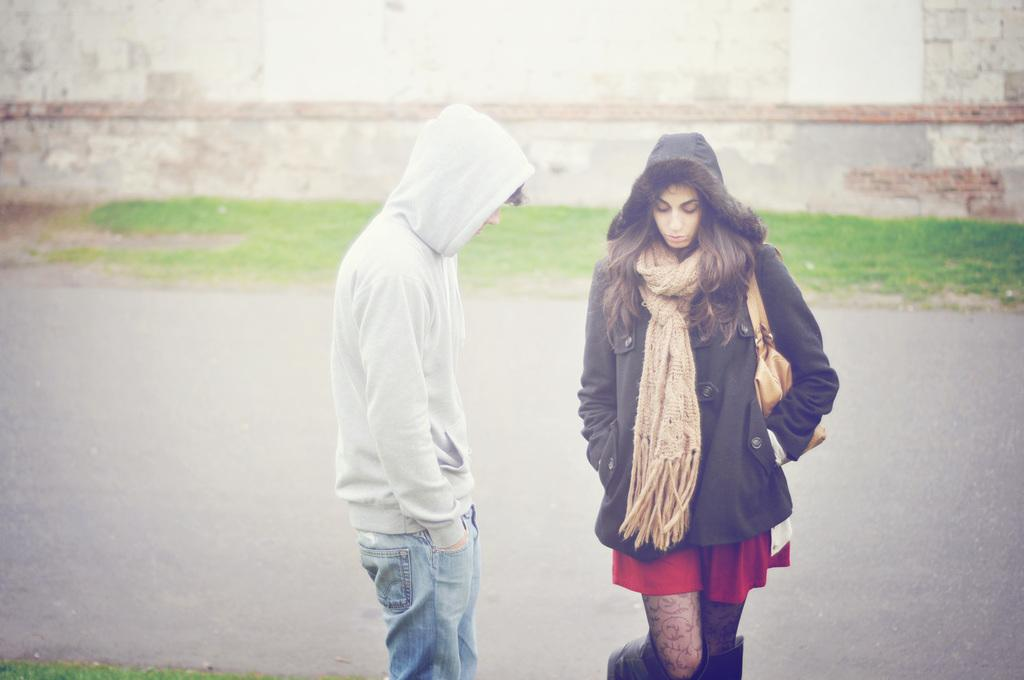How many people are in the image? There are two persons in the image. What type of surface is visible in the image? There is ground with grass in the image. What else can be seen in the image besides the persons and grass? There is a road and a wall in the image. What type of cracker is being used as a prop in the image? There is no cracker present in the image. What reason do the two persons have for being in the image? The provided facts do not give any information about the reason for the two persons being in the image. 